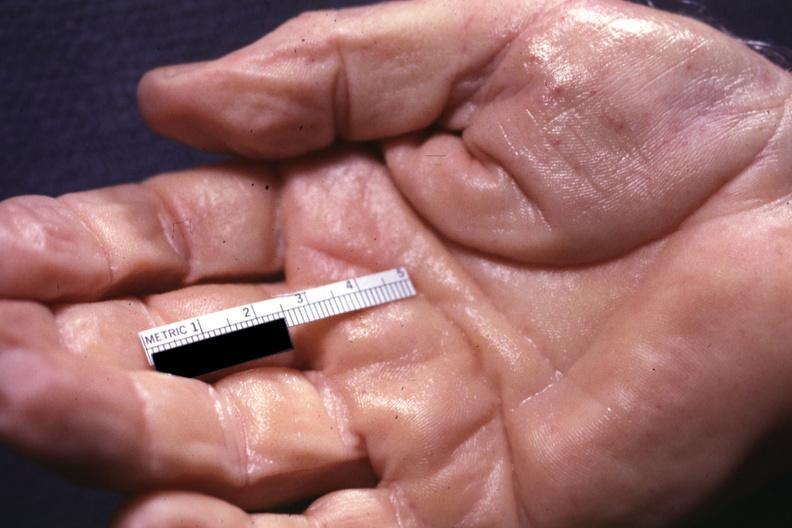what is present?
Answer the question using a single word or phrase. Hand 